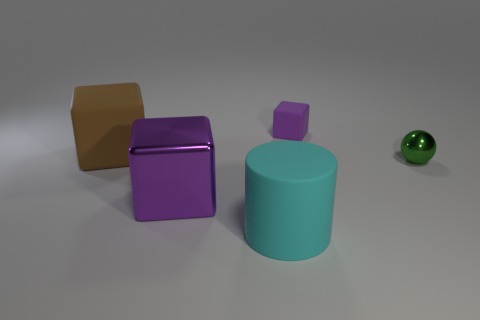Are there fewer purple blocks in front of the tiny green metal ball than big purple objects that are behind the small purple rubber thing?
Your response must be concise. No. How many other things are there of the same shape as the cyan thing?
Keep it short and to the point. 0. Are there fewer cyan objects in front of the cyan cylinder than gray balls?
Offer a terse response. No. There is a purple cube in front of the brown block; what material is it?
Provide a short and direct response. Metal. How many other things are there of the same size as the cyan object?
Make the answer very short. 2. Are there fewer yellow rubber spheres than big purple shiny things?
Your response must be concise. Yes. The large cyan object is what shape?
Provide a short and direct response. Cylinder. There is a large object right of the big purple shiny thing; is its color the same as the large rubber block?
Provide a succinct answer. No. What shape is the big thing that is both behind the cyan thing and to the right of the brown cube?
Provide a short and direct response. Cube. The large matte thing behind the small green ball is what color?
Give a very brief answer. Brown. 